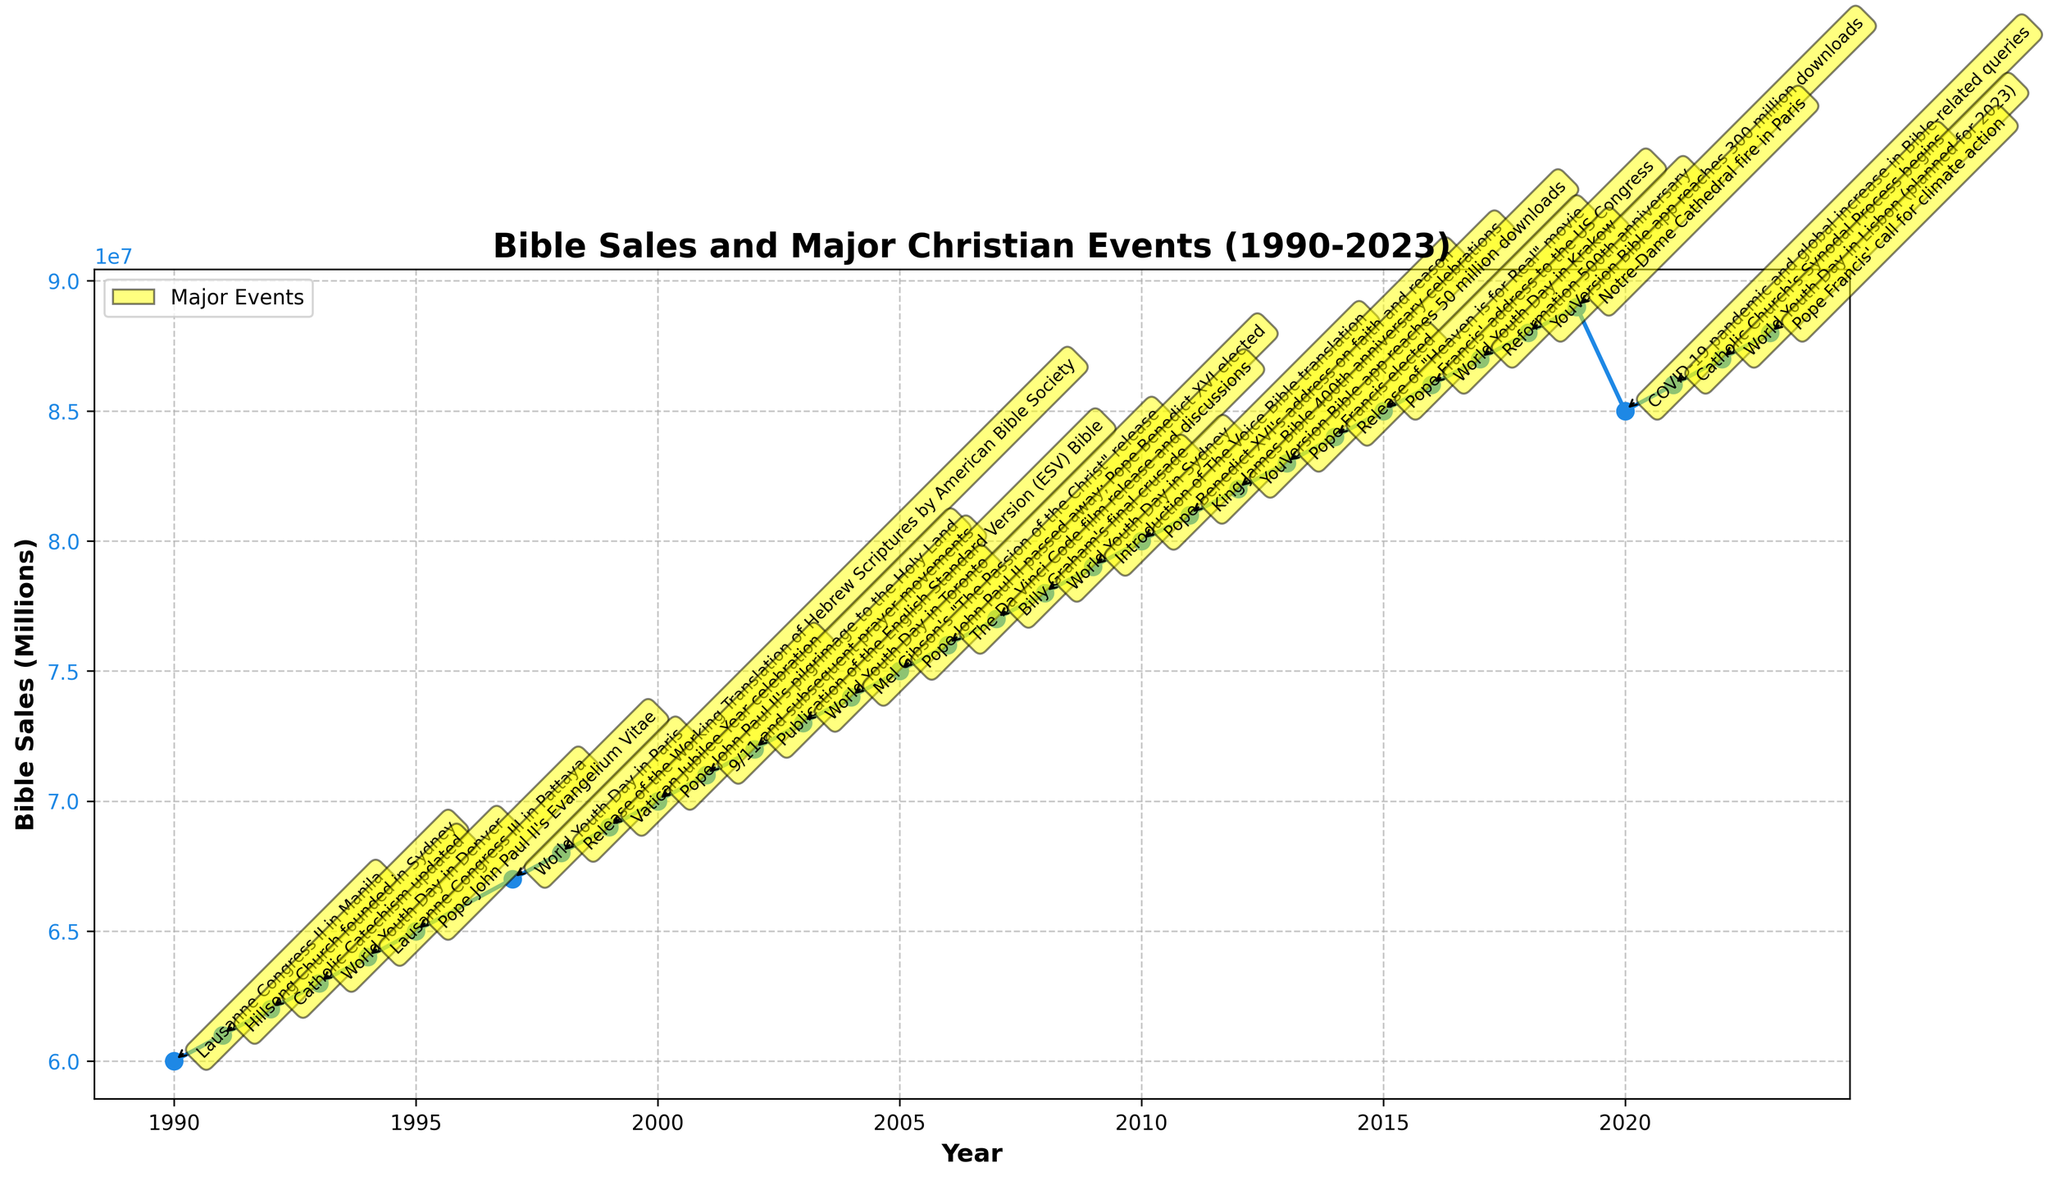what is the title of the plot? The title of the plot is usually located at the top of the figure and describes what the plot is about. In this case, the title would describe both the Bible sales and major Christian events from 1990 to 2023.
Answer: "Bible Sales and Major Christian Events (1990-2023)" what is the trend in bible sales from 1990 to 2023? To determine the trend, observe the general direction of the plotted line from 1990 to 2023. The sales consistently increase over these years, except for a notable decline around 2020.
Answer: Increasing trend with a dip in 2020 how does the major event in 2000 correlate with bible sales? Look at the major event annotation in 2000, "Pope John Paul II's pilgrimage to the Holy Land," and note the corresponding Bible sales at this point. Compare the sales value here with previous years to see any changes.
Answer: Bible sales continue to increase without any abrupt change what is the significance of the highest bible sales year in the dataset? Find the year with the highest Bible sales by looking at the peak of the plotted line and read the major event annotation associated with that peak to understand its context. The highest sales were in 2019, a year marked by the Notre-Dame Cathedral fire.
Answer: Notre-Dame Cathedral fire in 2019 what event aligns with the largest dip in bible sales? To find the largest dip, identify the portion of the line that shows a decrease. This major dip appears between 2019 and 2020. Look at the annotations in these years to identify the major events.
Answer: COVID-19 pandemic in 2020 what is the average increase in bible sales per year from 1990 to 2019? To calculate this, sum the increases in Bible sales for each year from 1990 to 2019 and divide by the number of years (2019-1990 = 29). This involves finding the sales each year, summing the increases, and dividing by 29. Sum of increases = (61-60) + (62-61) ... (89-88) = 29, then divide by 29 to find the consistent annual increase.
Answer: Approximately 1 million per year which years had events related to the world youth day? Read through the annotations and note the years, ensuring they relate to the World Youth Day. This event occurred in multiple years.
Answer: 1993, 1997, 2003, 2008, 2016, 2023 how do bible sales in 2010 compare to 2001? Locate the Bible sales values for both 2010 and 2001 on the y-axis and compare them. In 2010, the sales were 80 million, whereas in 2001, they were 71 million.
Answer: 2010 had 9 million higher sales than 2001 what are the trends in bible sales before and after the 2019 Notre-Dame Cathedral fire? Examine the sales values in years before 2019 compared to years after 2019. Sales fluctuated before the event with an increasing trend, peaked in 2019, then dropped in 2020 before increasing again.
Answer: Increased until 2019, then dropped in 2020 before recovering 